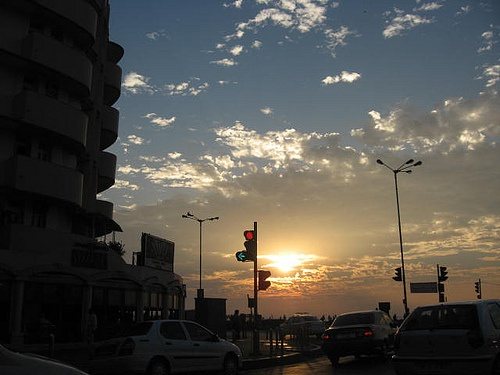Describe the objects in this image and their specific colors. I can see car in black and gray tones, car in black and gray tones, car in black, maroon, and gray tones, traffic light in black, maroon, brown, and teal tones, and people in black tones in this image. 